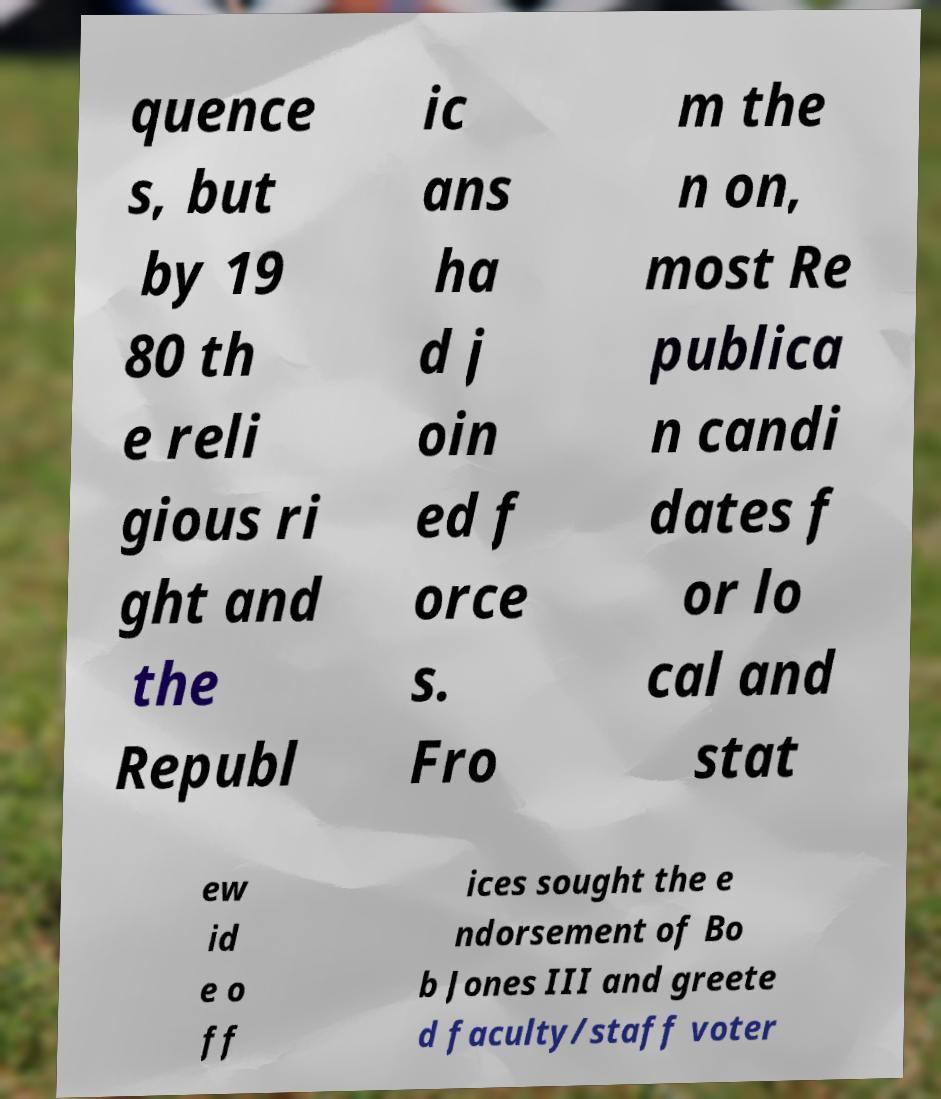There's text embedded in this image that I need extracted. Can you transcribe it verbatim? quence s, but by 19 80 th e reli gious ri ght and the Republ ic ans ha d j oin ed f orce s. Fro m the n on, most Re publica n candi dates f or lo cal and stat ew id e o ff ices sought the e ndorsement of Bo b Jones III and greete d faculty/staff voter 